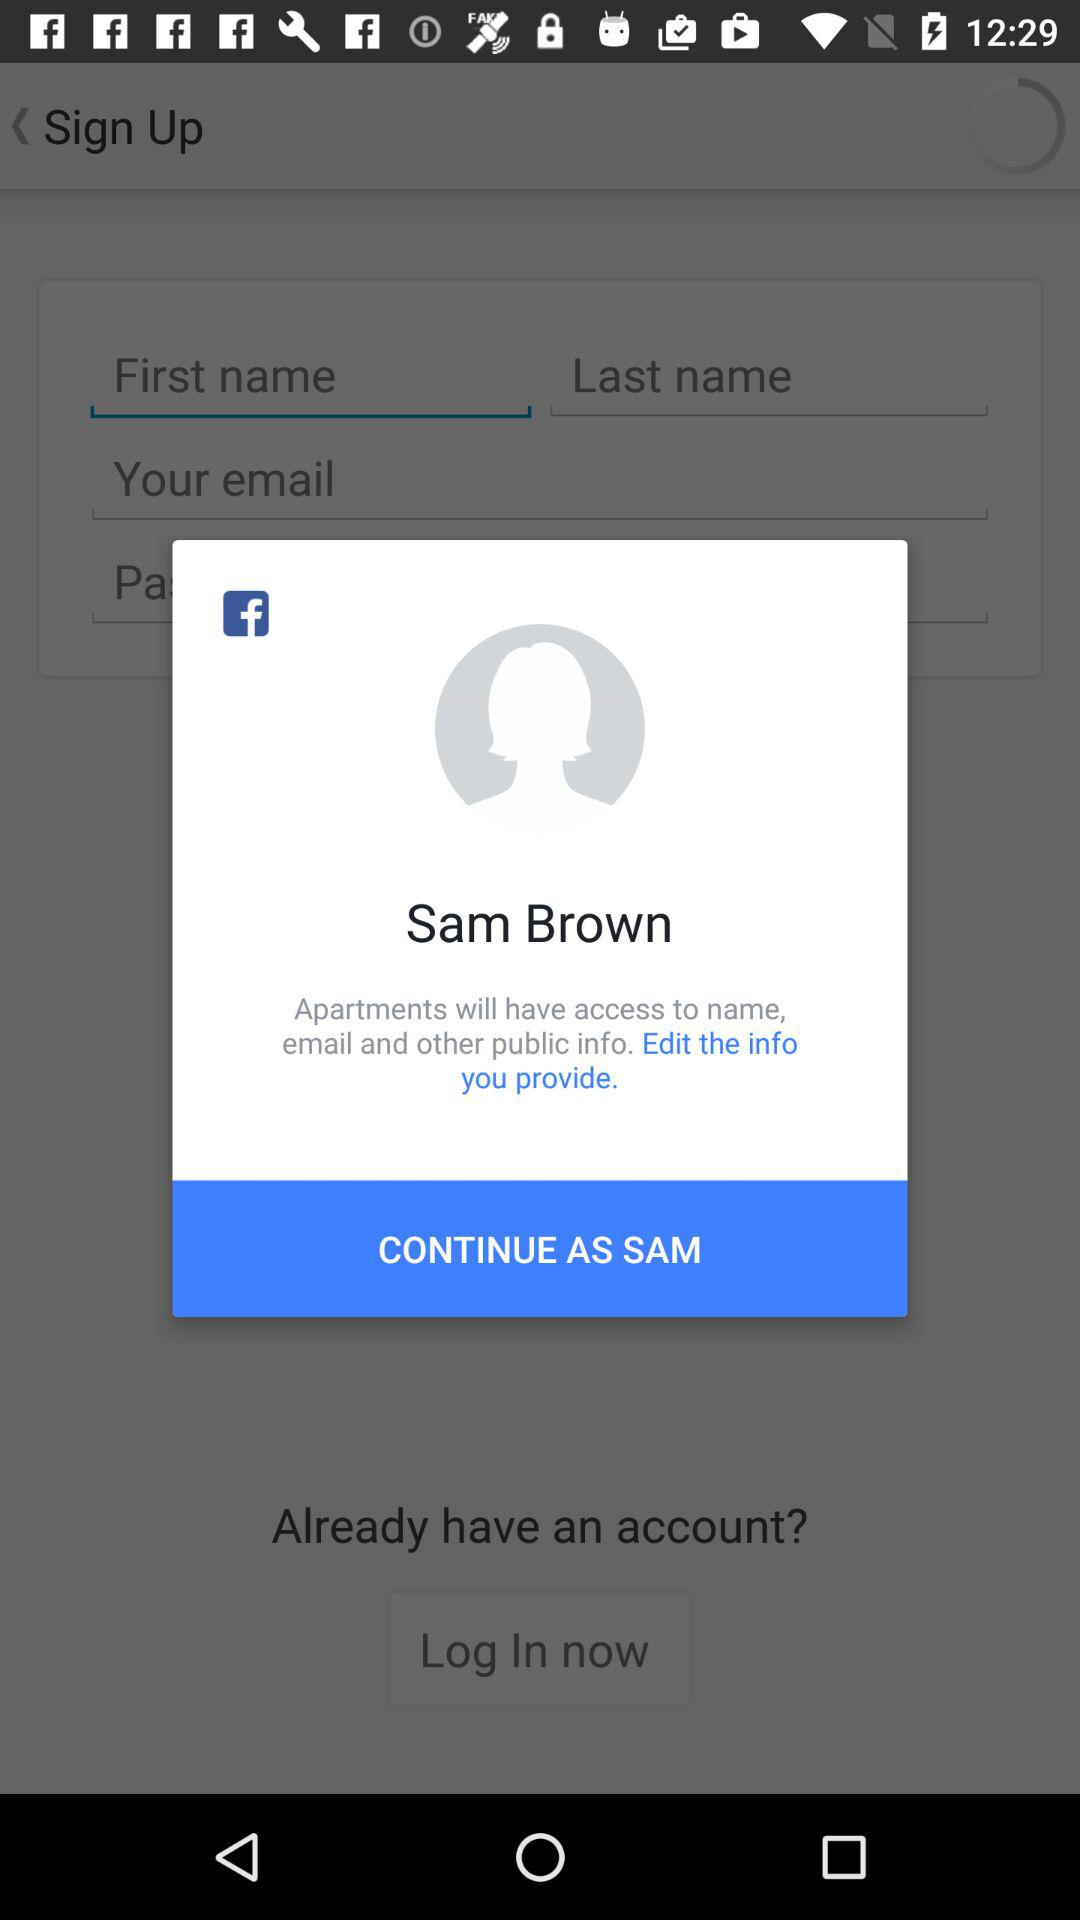What application is asking for permissions? The application is "Apartments". 